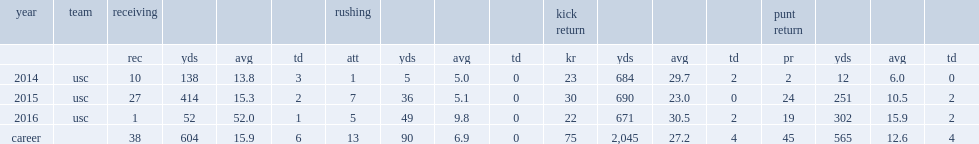In the 2015 season, how many receptions did jackson finish with 414 receiving yards? 27.0. 